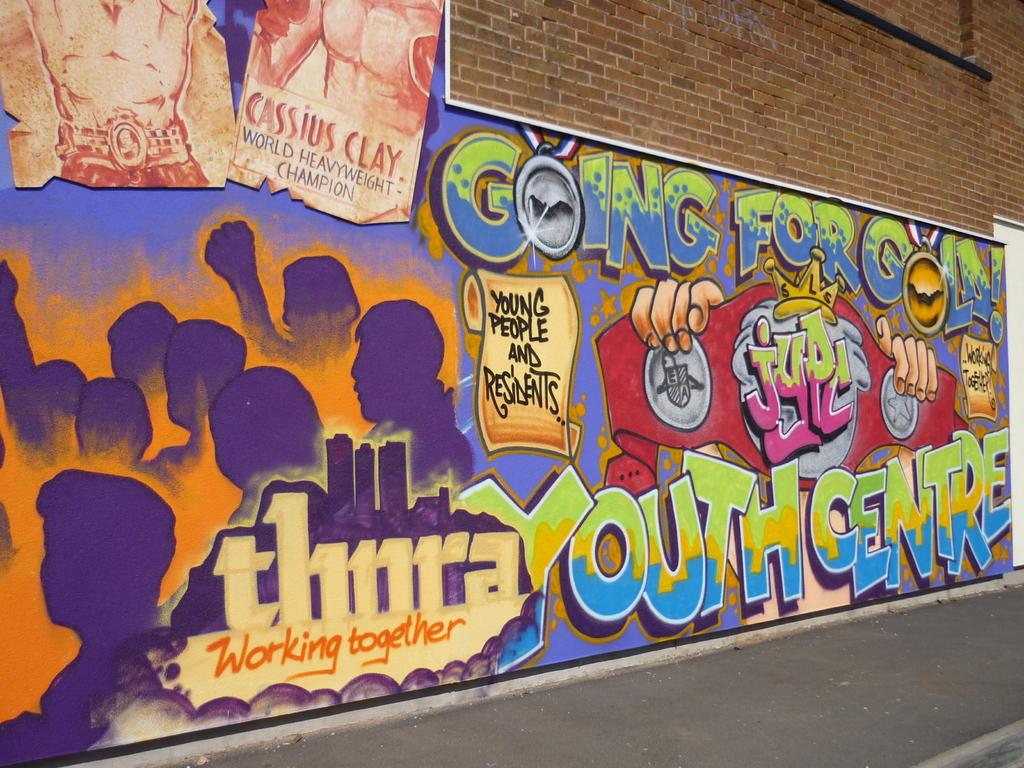What can be seen on the wall in the image? There is graffiti on the wall in the image. What type of wall is the graffiti on? The graffiti is on a brick wall. How many deer are present in the image? There are no deer visible in the image; it features graffiti on a brick wall. What decision is being made in the image? There is no indication of a decision being made in the image, as it only shows graffiti on a brick wall. 